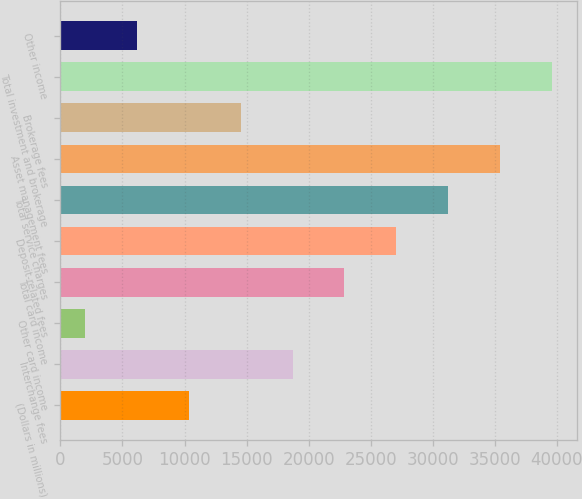Convert chart. <chart><loc_0><loc_0><loc_500><loc_500><bar_chart><fcel>(Dollars in millions)<fcel>Interchange fees<fcel>Other card income<fcel>Total card income<fcel>Deposit-related fees<fcel>Total service charges<fcel>Asset management fees<fcel>Brokerage fees<fcel>Total investment and brokerage<fcel>Other income<nl><fcel>10329.4<fcel>18700.8<fcel>1958<fcel>22886.5<fcel>27072.2<fcel>31257.9<fcel>35443.6<fcel>14515.1<fcel>39629.3<fcel>6143.7<nl></chart> 